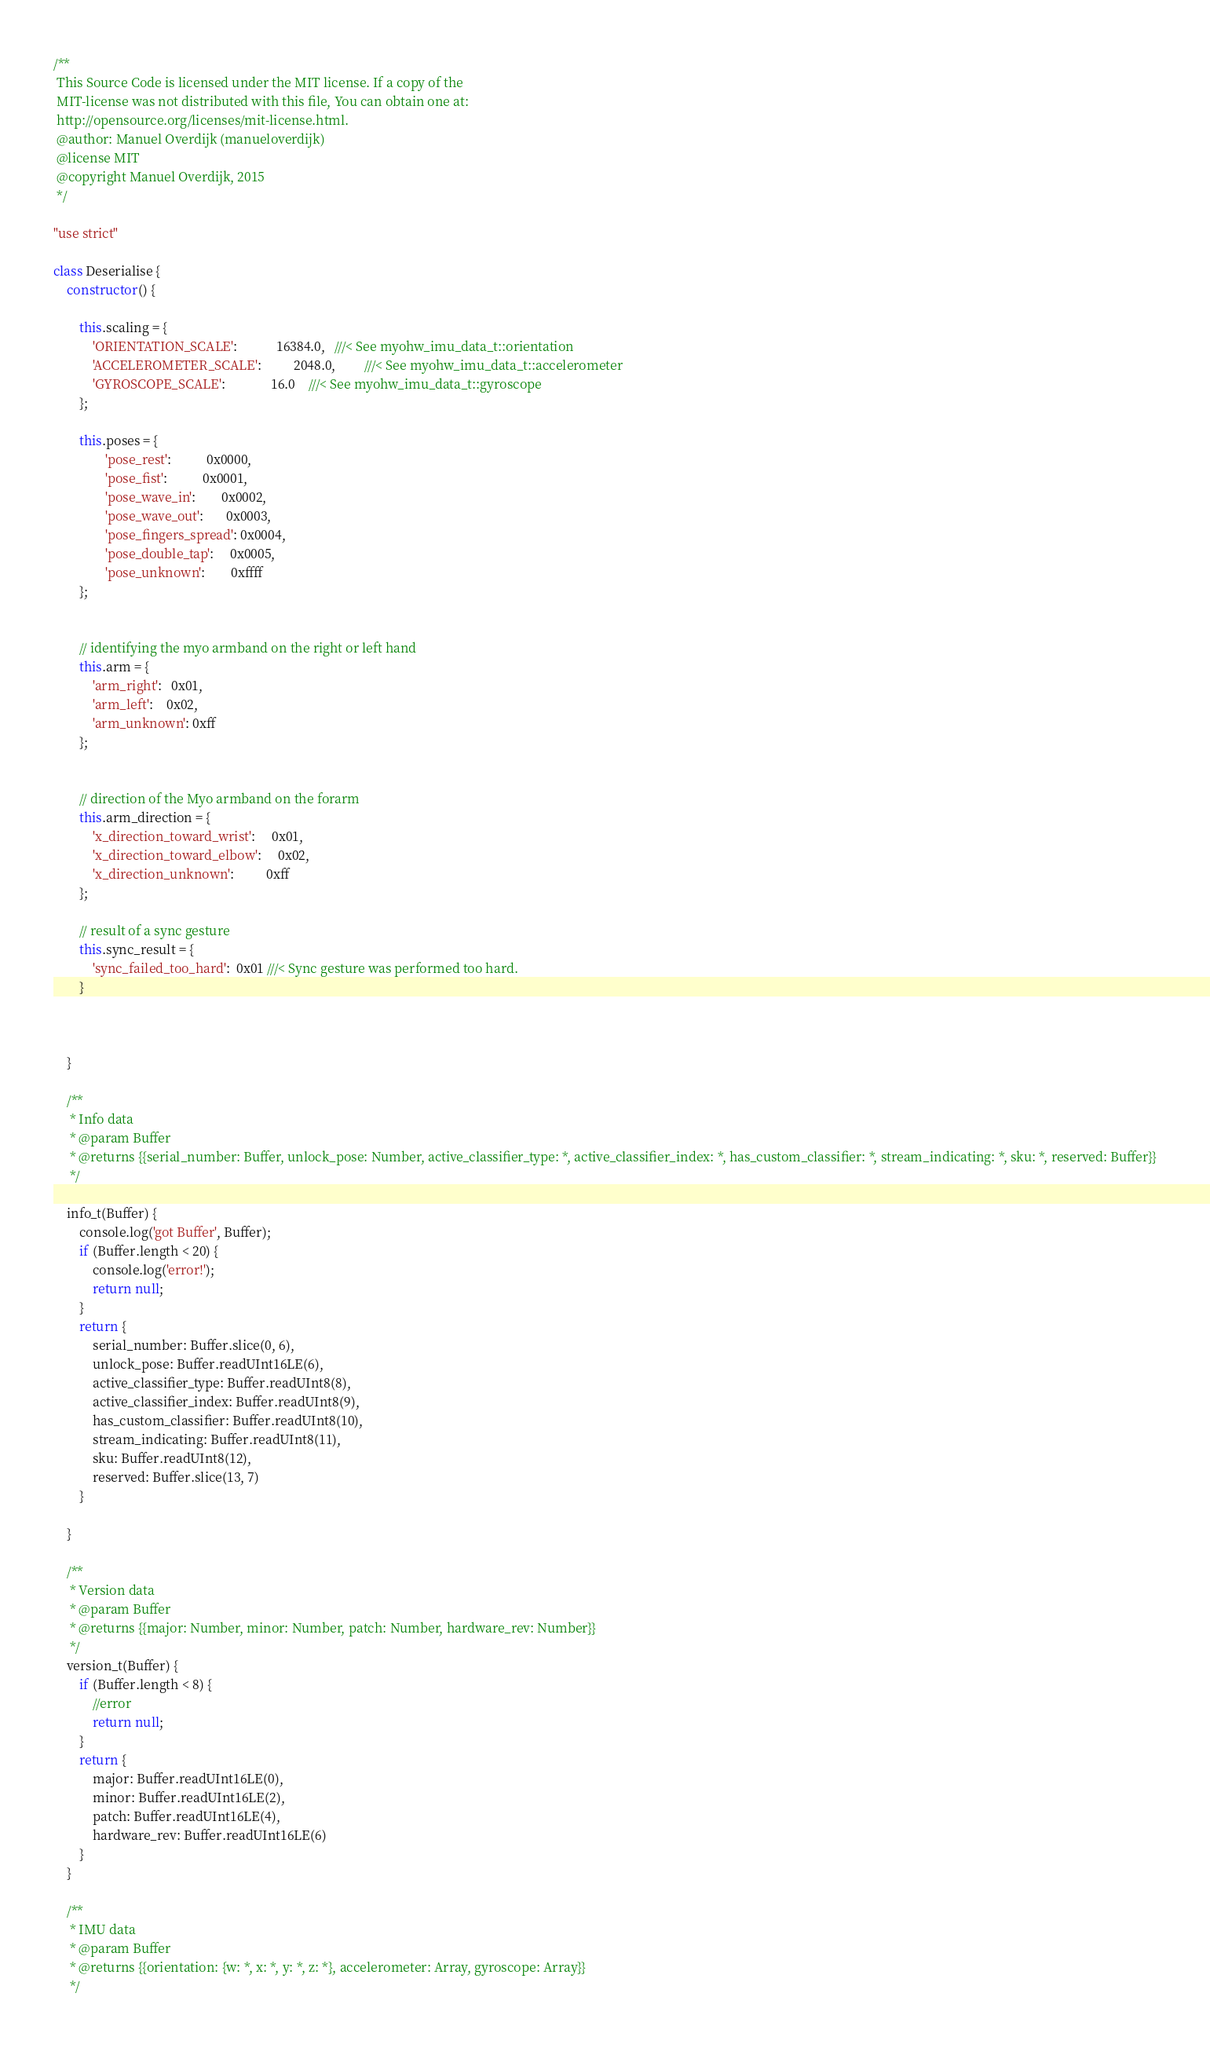Convert code to text. <code><loc_0><loc_0><loc_500><loc_500><_JavaScript_>/**
 This Source Code is licensed under the MIT license. If a copy of the
 MIT-license was not distributed with this file, You can obtain one at:
 http://opensource.org/licenses/mit-license.html.
 @author: Manuel Overdijk (manueloverdijk)
 @license MIT
 @copyright Manuel Overdijk, 2015
 */

"use strict"

class Deserialise {
    constructor() {

        this.scaling = {
            'ORIENTATION_SCALE':            16384.0,   ///< See myohw_imu_data_t::orientation
            'ACCELEROMETER_SCALE':          2048.0,         ///< See myohw_imu_data_t::accelerometer
            'GYROSCOPE_SCALE':              16.0    ///< See myohw_imu_data_t::gyroscope
        };

        this.poses = {
                'pose_rest':           0x0000,
                'pose_fist':           0x0001,
                'pose_wave_in':        0x0002,
                'pose_wave_out':       0x0003,
                'pose_fingers_spread': 0x0004,
                'pose_double_tap':     0x0005,
                'pose_unknown':        0xffff
        };


        // identifying the myo armband on the right or left hand
        this.arm = {
            'arm_right':   0x01,
            'arm_left':    0x02,
            'arm_unknown': 0xff
        };


        // direction of the Myo armband on the forarm
        this.arm_direction = {
            'x_direction_toward_wrist':     0x01,
            'x_direction_toward_elbow':     0x02,
            'x_direction_unknown':          0xff
        };

        // result of a sync gesture
        this.sync_result = {
            'sync_failed_too_hard':  0x01 ///< Sync gesture was performed too hard.
        }



    }

    /**
     * Info data
     * @param Buffer
     * @returns {{serial_number: Buffer, unlock_pose: Number, active_classifier_type: *, active_classifier_index: *, has_custom_classifier: *, stream_indicating: *, sku: *, reserved: Buffer}}
     */

    info_t(Buffer) {
        console.log('got Buffer', Buffer);
        if (Buffer.length < 20) {
            console.log('error!');
            return null;
        }
        return {
            serial_number: Buffer.slice(0, 6),
            unlock_pose: Buffer.readUInt16LE(6),
            active_classifier_type: Buffer.readUInt8(8),
            active_classifier_index: Buffer.readUInt8(9),
            has_custom_classifier: Buffer.readUInt8(10),
            stream_indicating: Buffer.readUInt8(11),
            sku: Buffer.readUInt8(12),
            reserved: Buffer.slice(13, 7)
        }

    }

    /**
     * Version data
     * @param Buffer
     * @returns {{major: Number, minor: Number, patch: Number, hardware_rev: Number}}
     */
    version_t(Buffer) {
        if (Buffer.length < 8) {
            //error
            return null;
        }
        return {
            major: Buffer.readUInt16LE(0),
            minor: Buffer.readUInt16LE(2),
            patch: Buffer.readUInt16LE(4),
            hardware_rev: Buffer.readUInt16LE(6)
        }
    }

    /**
     * IMU data
     * @param Buffer
     * @returns {{orientation: {w: *, x: *, y: *, z: *}, accelerometer: Array, gyroscope: Array}}
     */</code> 